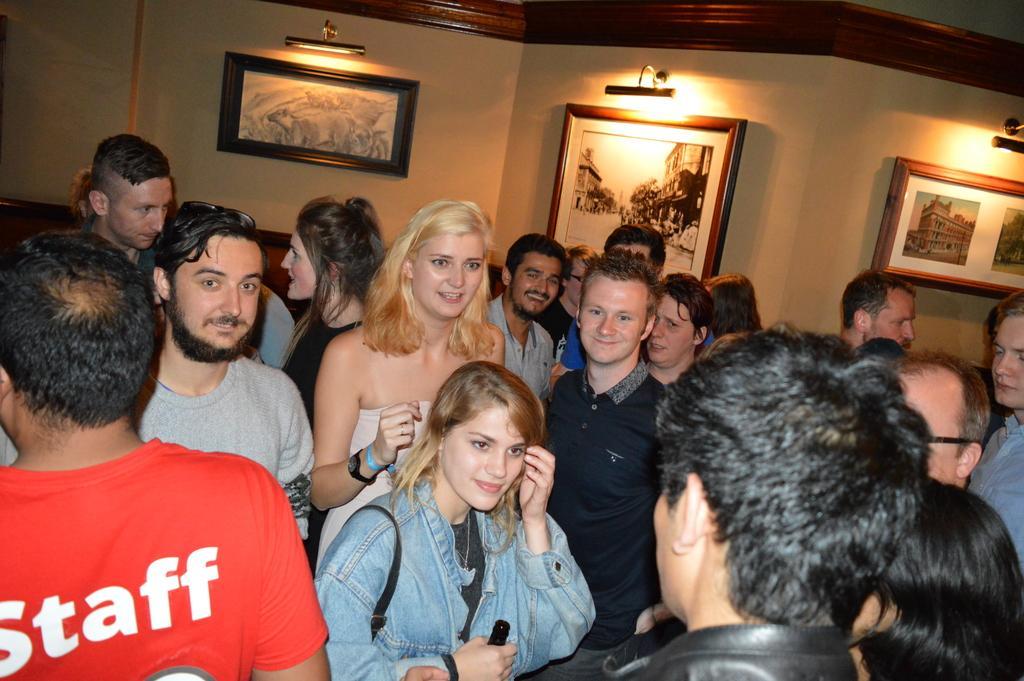Please provide a concise description of this image. In this image we can see people. In the background there is a wall and lights. There are photo frames placed on the wall. 